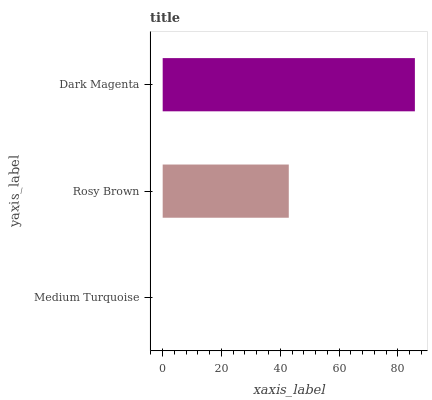Is Medium Turquoise the minimum?
Answer yes or no. Yes. Is Dark Magenta the maximum?
Answer yes or no. Yes. Is Rosy Brown the minimum?
Answer yes or no. No. Is Rosy Brown the maximum?
Answer yes or no. No. Is Rosy Brown greater than Medium Turquoise?
Answer yes or no. Yes. Is Medium Turquoise less than Rosy Brown?
Answer yes or no. Yes. Is Medium Turquoise greater than Rosy Brown?
Answer yes or no. No. Is Rosy Brown less than Medium Turquoise?
Answer yes or no. No. Is Rosy Brown the high median?
Answer yes or no. Yes. Is Rosy Brown the low median?
Answer yes or no. Yes. Is Medium Turquoise the high median?
Answer yes or no. No. Is Medium Turquoise the low median?
Answer yes or no. No. 